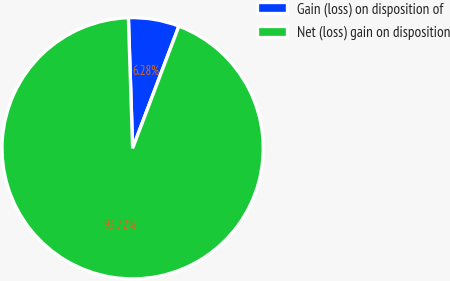Convert chart. <chart><loc_0><loc_0><loc_500><loc_500><pie_chart><fcel>Gain (loss) on disposition of<fcel>Net (loss) gain on disposition<nl><fcel>6.28%<fcel>93.72%<nl></chart> 